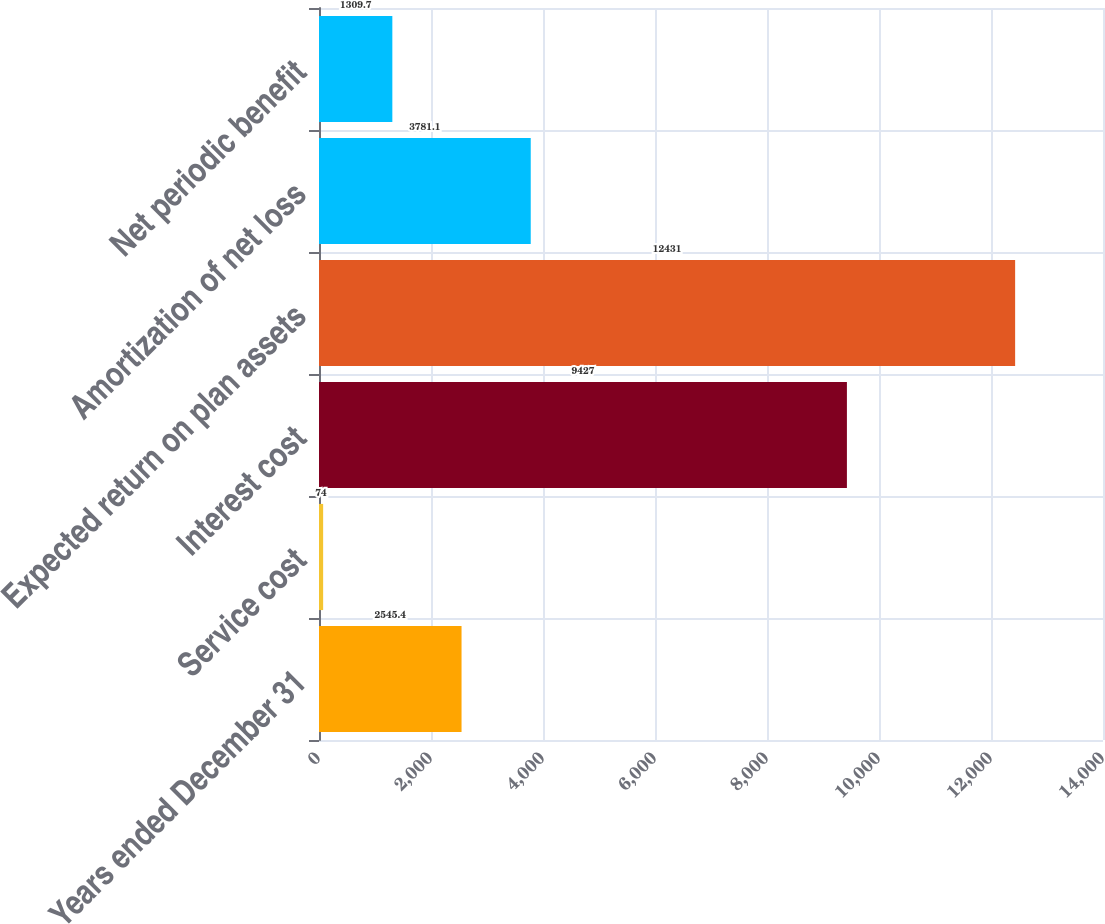Convert chart. <chart><loc_0><loc_0><loc_500><loc_500><bar_chart><fcel>Years ended December 31<fcel>Service cost<fcel>Interest cost<fcel>Expected return on plan assets<fcel>Amortization of net loss<fcel>Net periodic benefit<nl><fcel>2545.4<fcel>74<fcel>9427<fcel>12431<fcel>3781.1<fcel>1309.7<nl></chart> 